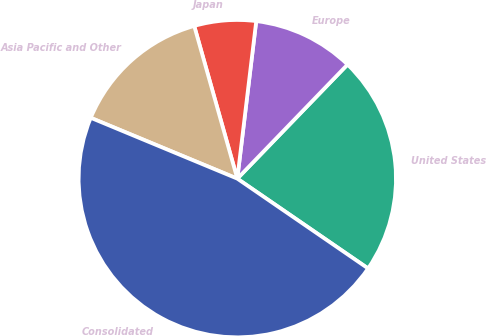Convert chart to OTSL. <chart><loc_0><loc_0><loc_500><loc_500><pie_chart><fcel>United States<fcel>Europe<fcel>Japan<fcel>Asia Pacific and Other<fcel>Consolidated<nl><fcel>22.35%<fcel>10.32%<fcel>6.28%<fcel>14.36%<fcel>46.68%<nl></chart> 